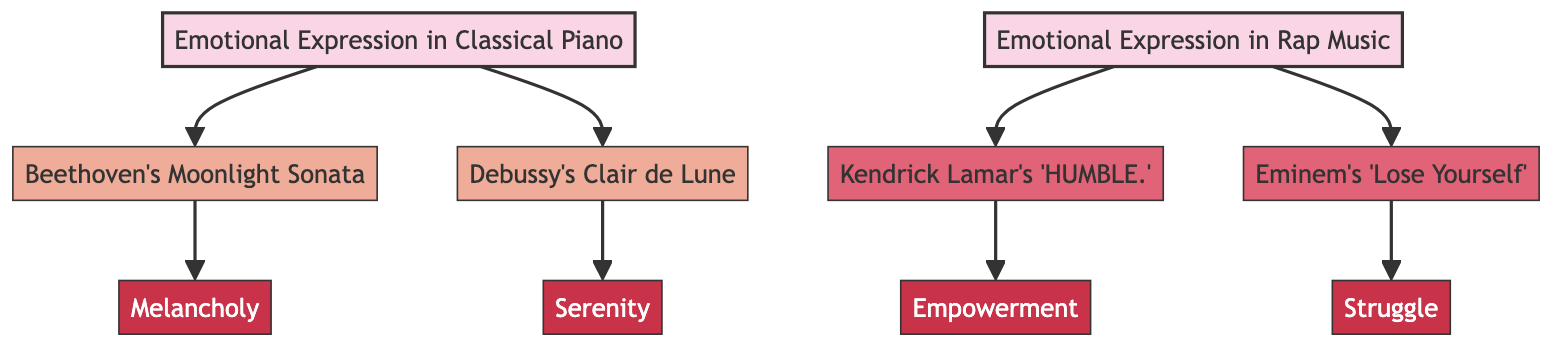What are the two classical pieces mentioned in the diagram? The diagram lists two classical pieces: Beethoven's Moonlight Sonata and Debussy's Clair de Lune. Both are connected to the node for emotional expression in classical piano.
Answer: Beethoven's Moonlight Sonata, Debussy's Clair de Lune How many edges are in the diagram? By counting the connections (edges) between nodes, there are eight edges shown in the diagram, linking classical pieces, rap songs, and emotions.
Answer: 8 What emotion is associated with Debussy's Clair de Lune? The diagram shows a connection from Debussy's Clair de Lune to the node labeled Serenity, indicating that this piece expresses the emotion of serenity.
Answer: Serenity Which rapper's song expresses the theme of empowerment? Looking at the node labeled rap_emotion, its connection to Kendrick Lamar's song 'HUMBLE.' indicates that it expresses the theme of empowerment.
Answer: Kendrick Lamar's 'HUMBLE.' How many emotional expressions are listed in the classical section? The classical section has two emotional expressions: Melancholy and Serenity, which are each connected to the respective classical pieces in the diagram.
Answer: 2 Which two emotions are noted in the rap section? The diagram shows that the rap section has two emotions associated: Empowerment and Struggle, each linked to the respective rap songs.
Answer: Empowerment, Struggle What is the connection between Beethoven's Moonlight Sonata and melancholy? The diagram shows that there is a direct connection from Beethoven's Moonlight Sonata to the emotion of Melancholy, indicating it represents this emotion.
Answer: Melancholy Which type of music does "Lose Yourself" belong to? The node for Eminem's "Lose Yourself" is connected to the rap_music category in the diagram, distinguishing it as part of rap music.
Answer: Rap music 